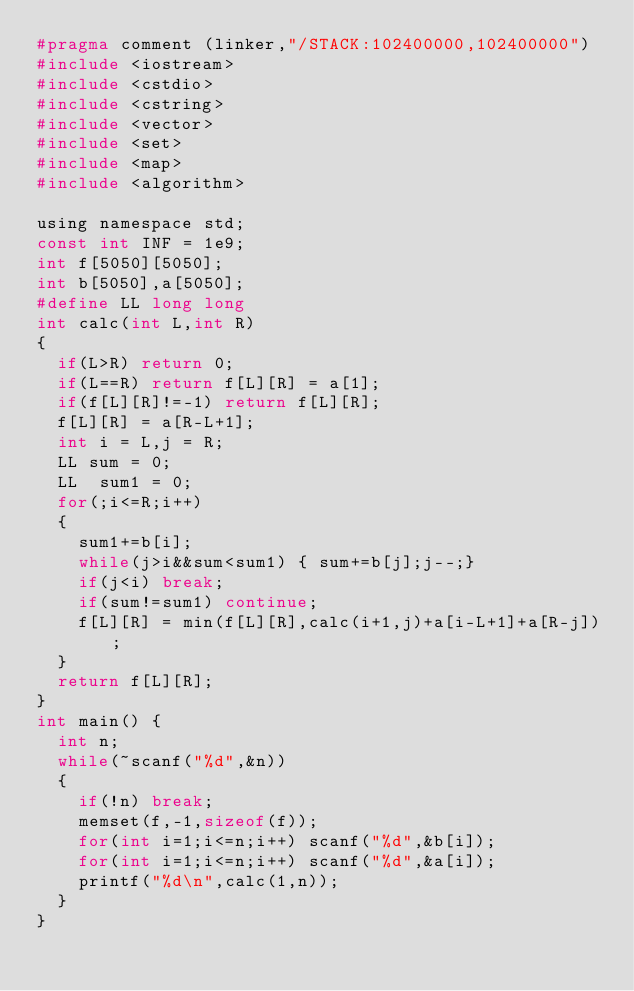<code> <loc_0><loc_0><loc_500><loc_500><_C_>#pragma comment (linker,"/STACK:102400000,102400000")
#include <iostream>
#include <cstdio>
#include <cstring>
#include <vector>
#include <set>
#include <map>
#include <algorithm>

using namespace std;
const int INF = 1e9;
int f[5050][5050];
int b[5050],a[5050];
#define LL long long
int calc(int L,int R)
{
	if(L>R) return 0;
	if(L==R) return f[L][R] = a[1];
	if(f[L][R]!=-1) return f[L][R];
	f[L][R] = a[R-L+1];
	int i = L,j = R;
	LL sum = 0;
	LL  sum1 = 0;
	for(;i<=R;i++)
	{
		sum1+=b[i];
		while(j>i&&sum<sum1) { sum+=b[j];j--;}
		if(j<i) break;
		if(sum!=sum1) continue;
		f[L][R] = min(f[L][R],calc(i+1,j)+a[i-L+1]+a[R-j]);
	}
	return f[L][R];
}
int main() {
	int n;
	while(~scanf("%d",&n))
	{
		if(!n) break;
		memset(f,-1,sizeof(f));
		for(int i=1;i<=n;i++) scanf("%d",&b[i]);
		for(int i=1;i<=n;i++) scanf("%d",&a[i]);
		printf("%d\n",calc(1,n));
	}
}</code> 